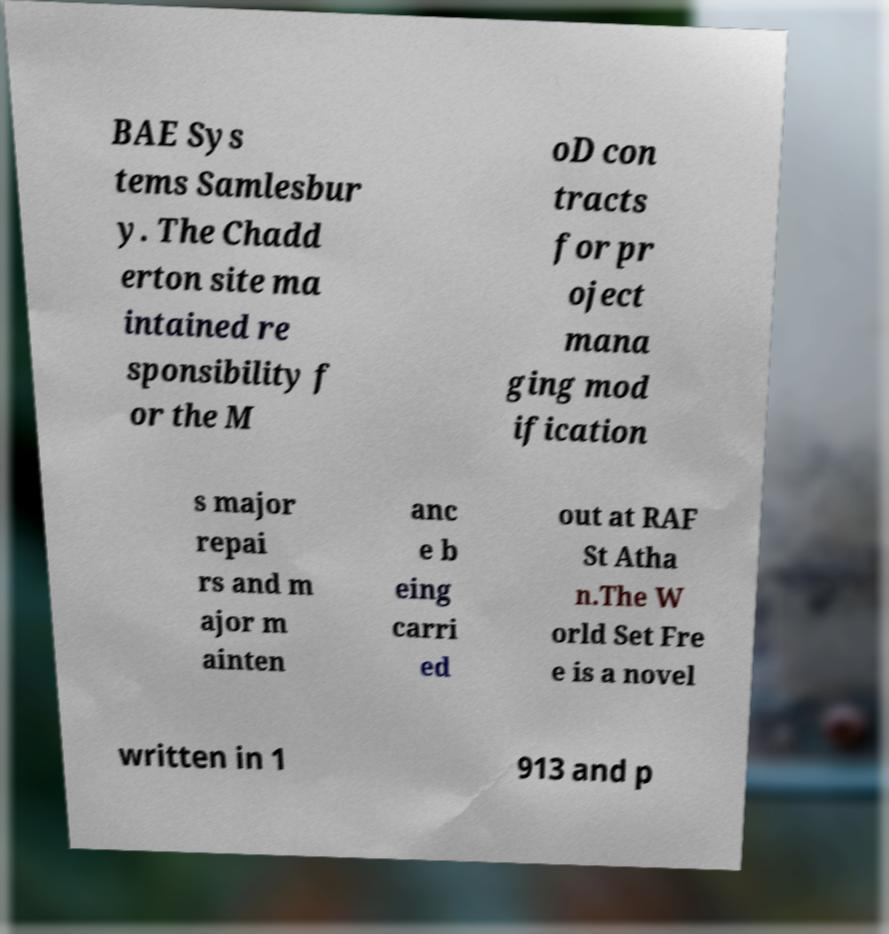I need the written content from this picture converted into text. Can you do that? BAE Sys tems Samlesbur y. The Chadd erton site ma intained re sponsibility f or the M oD con tracts for pr oject mana ging mod ification s major repai rs and m ajor m ainten anc e b eing carri ed out at RAF St Atha n.The W orld Set Fre e is a novel written in 1 913 and p 